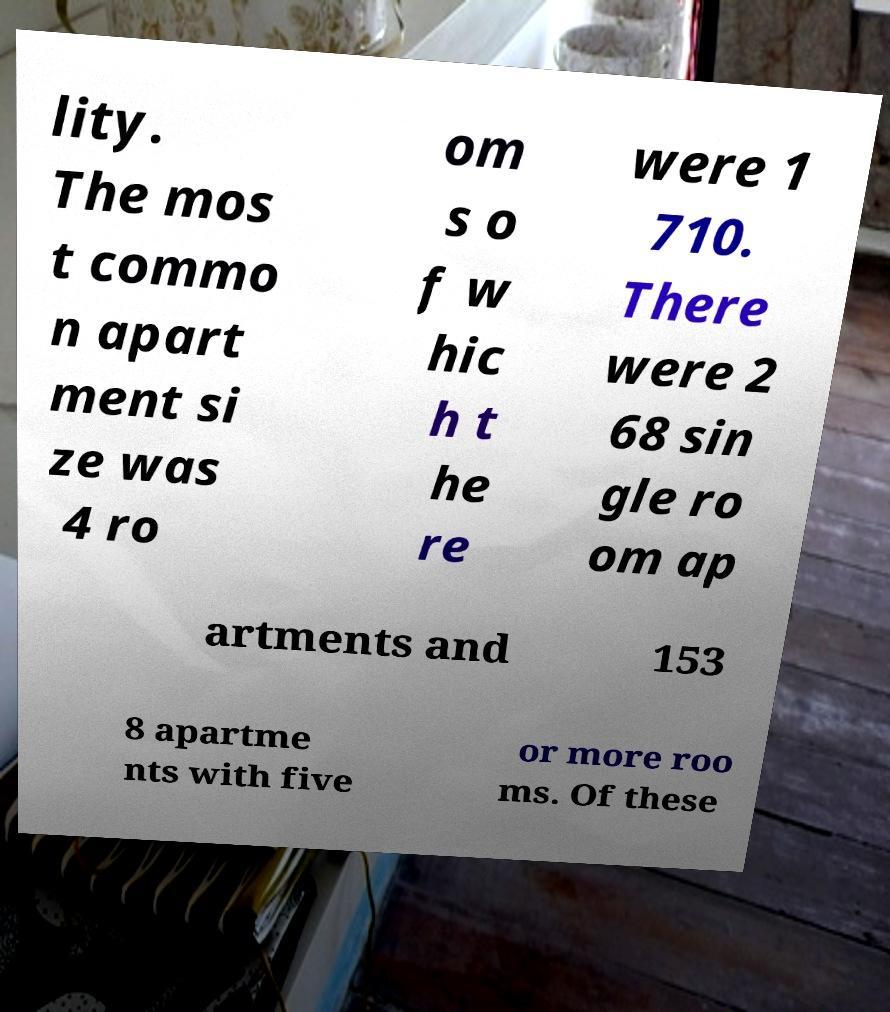There's text embedded in this image that I need extracted. Can you transcribe it verbatim? lity. The mos t commo n apart ment si ze was 4 ro om s o f w hic h t he re were 1 710. There were 2 68 sin gle ro om ap artments and 153 8 apartme nts with five or more roo ms. Of these 